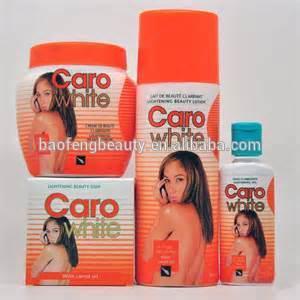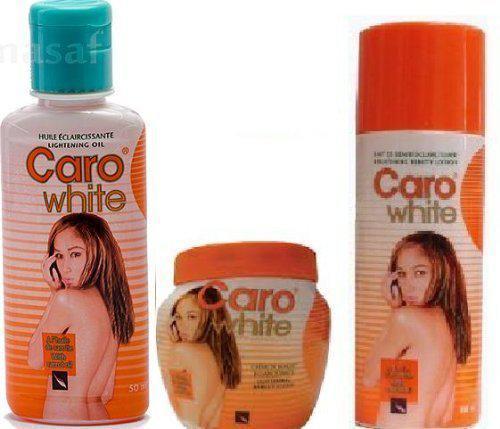The first image is the image on the left, the second image is the image on the right. Analyze the images presented: Is the assertion "Each image includes a squat, roundish jar with a flat orange lid, and at least one image also includes a cylinder-shaped bottle and orange cap, and a bottle with a blue cap." valid? Answer yes or no. Yes. 